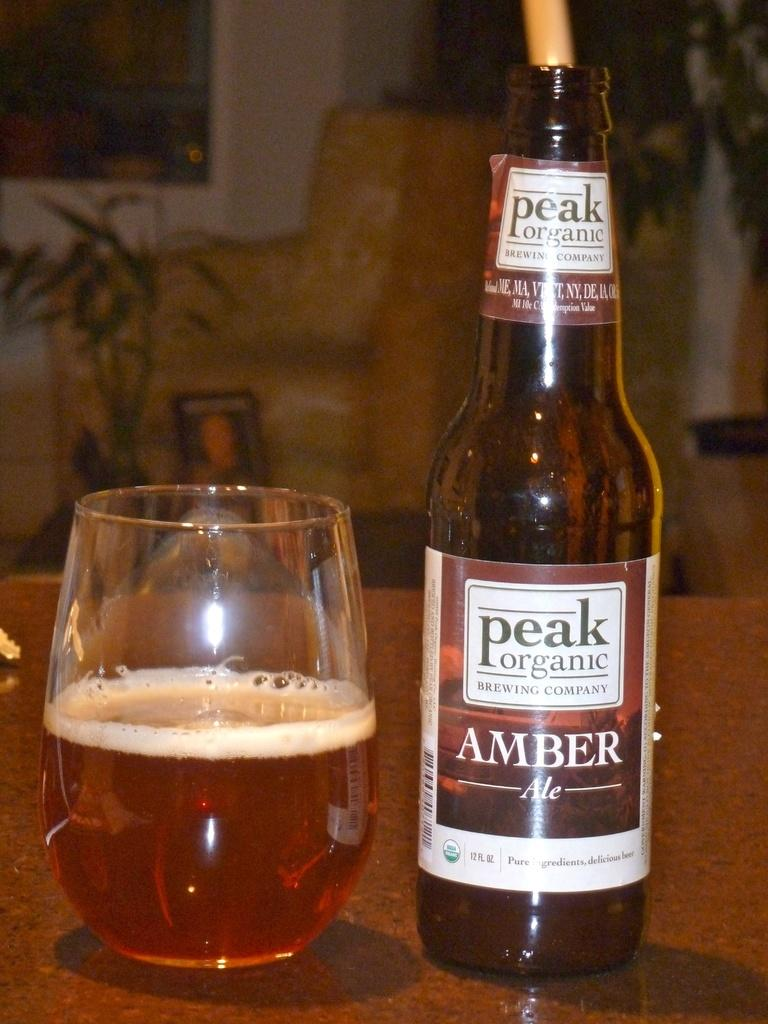Provide a one-sentence caption for the provided image. A bottle of Peak Organic Amber beer next to a glass. 